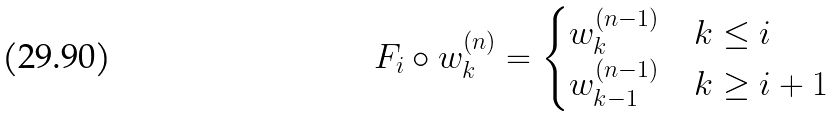Convert formula to latex. <formula><loc_0><loc_0><loc_500><loc_500>F _ { i } \circ w _ { k } ^ { ( n ) } = \begin{cases} w _ { k } ^ { ( n - 1 ) } & k \leq i \\ w _ { k - 1 } ^ { ( n - 1 ) } & k \geq i + 1 \end{cases}</formula> 